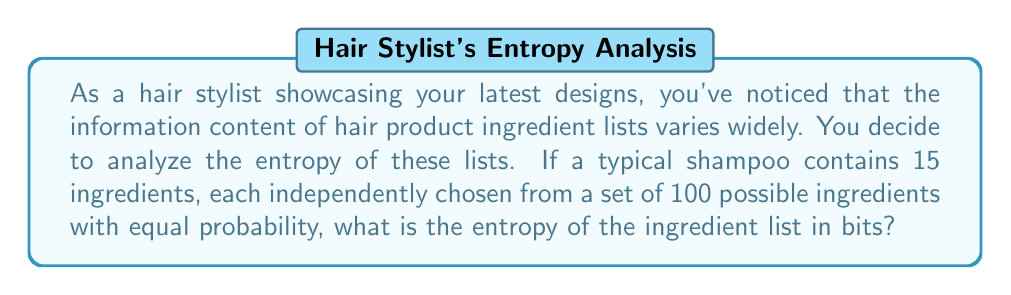Could you help me with this problem? To solve this problem, we'll use the concept of information entropy from information theory. The steps are as follows:

1) The entropy $H$ of a message with $n$ equally likely outcomes is given by:

   $$H = \log_2(n)$$ bits

2) In this case, for each ingredient, there are 100 possible choices, so the entropy for a single ingredient is:

   $$H_{single} = \log_2(100) = 6.64$$ bits

3) Since there are 15 ingredients, and each is chosen independently, we can treat this as 15 separate "messages". The total entropy is the sum of the entropies of each independent choice:

   $$H_{total} = 15 \times H_{single}$$

4) Substituting the value we calculated for $H_{single}$:

   $$H_{total} = 15 \times 6.64 = 99.6$$ bits

5) Rounding to one decimal place:

   $$H_{total} \approx 99.6$$ bits

This means that each ingredient list contains approximately 99.6 bits of information, which represents the average minimum number of yes/no questions you'd need to ask to determine the exact list of ingredients.
Answer: 99.6 bits 